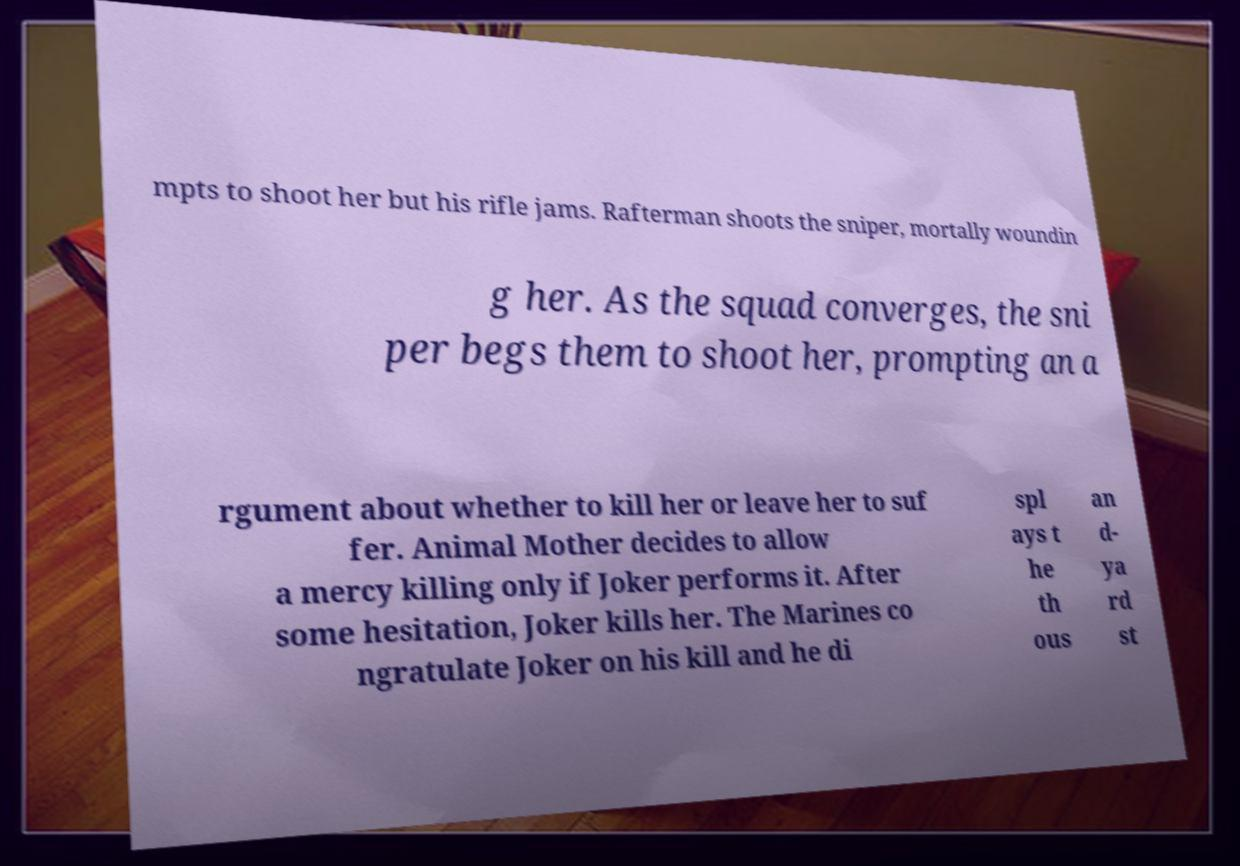Could you extract and type out the text from this image? mpts to shoot her but his rifle jams. Rafterman shoots the sniper, mortally woundin g her. As the squad converges, the sni per begs them to shoot her, prompting an a rgument about whether to kill her or leave her to suf fer. Animal Mother decides to allow a mercy killing only if Joker performs it. After some hesitation, Joker kills her. The Marines co ngratulate Joker on his kill and he di spl ays t he th ous an d- ya rd st 